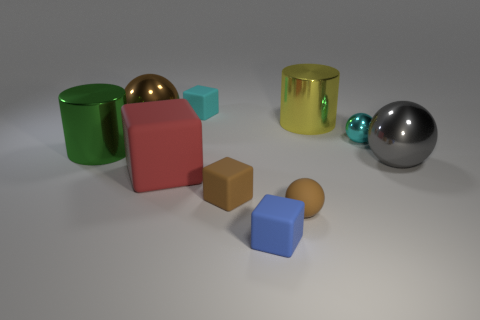Subtract all balls. How many objects are left? 6 Add 6 tiny cyan objects. How many tiny cyan objects exist? 8 Subtract 1 brown cubes. How many objects are left? 9 Subtract all tiny spheres. Subtract all big green things. How many objects are left? 7 Add 5 big red matte things. How many big red matte things are left? 6 